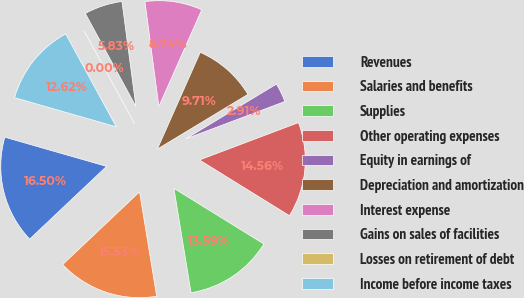Convert chart. <chart><loc_0><loc_0><loc_500><loc_500><pie_chart><fcel>Revenues<fcel>Salaries and benefits<fcel>Supplies<fcel>Other operating expenses<fcel>Equity in earnings of<fcel>Depreciation and amortization<fcel>Interest expense<fcel>Gains on sales of facilities<fcel>Losses on retirement of debt<fcel>Income before income taxes<nl><fcel>16.5%<fcel>15.53%<fcel>13.59%<fcel>14.56%<fcel>2.91%<fcel>9.71%<fcel>8.74%<fcel>5.83%<fcel>0.0%<fcel>12.62%<nl></chart> 